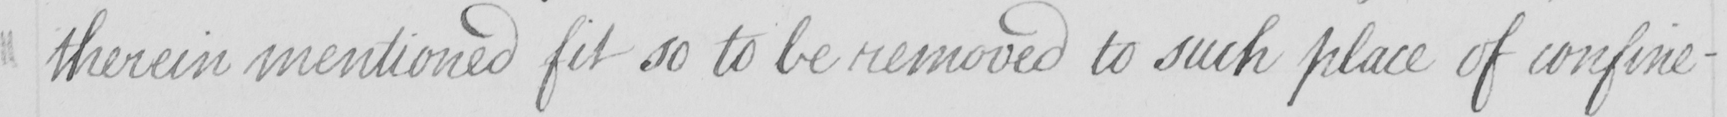Please transcribe the handwritten text in this image. therein mentioned fit so to be removed to such place of confine- 